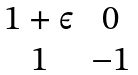Convert formula to latex. <formula><loc_0><loc_0><loc_500><loc_500>\begin{matrix} 1 + \varepsilon & 0 \\ 1 & - 1 \end{matrix}</formula> 